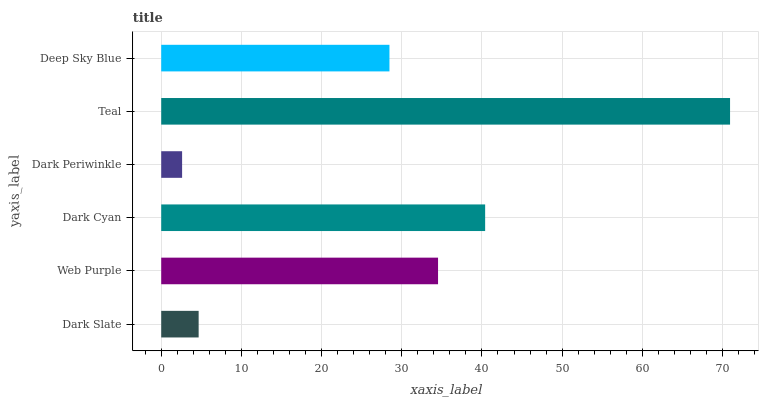Is Dark Periwinkle the minimum?
Answer yes or no. Yes. Is Teal the maximum?
Answer yes or no. Yes. Is Web Purple the minimum?
Answer yes or no. No. Is Web Purple the maximum?
Answer yes or no. No. Is Web Purple greater than Dark Slate?
Answer yes or no. Yes. Is Dark Slate less than Web Purple?
Answer yes or no. Yes. Is Dark Slate greater than Web Purple?
Answer yes or no. No. Is Web Purple less than Dark Slate?
Answer yes or no. No. Is Web Purple the high median?
Answer yes or no. Yes. Is Deep Sky Blue the low median?
Answer yes or no. Yes. Is Teal the high median?
Answer yes or no. No. Is Web Purple the low median?
Answer yes or no. No. 